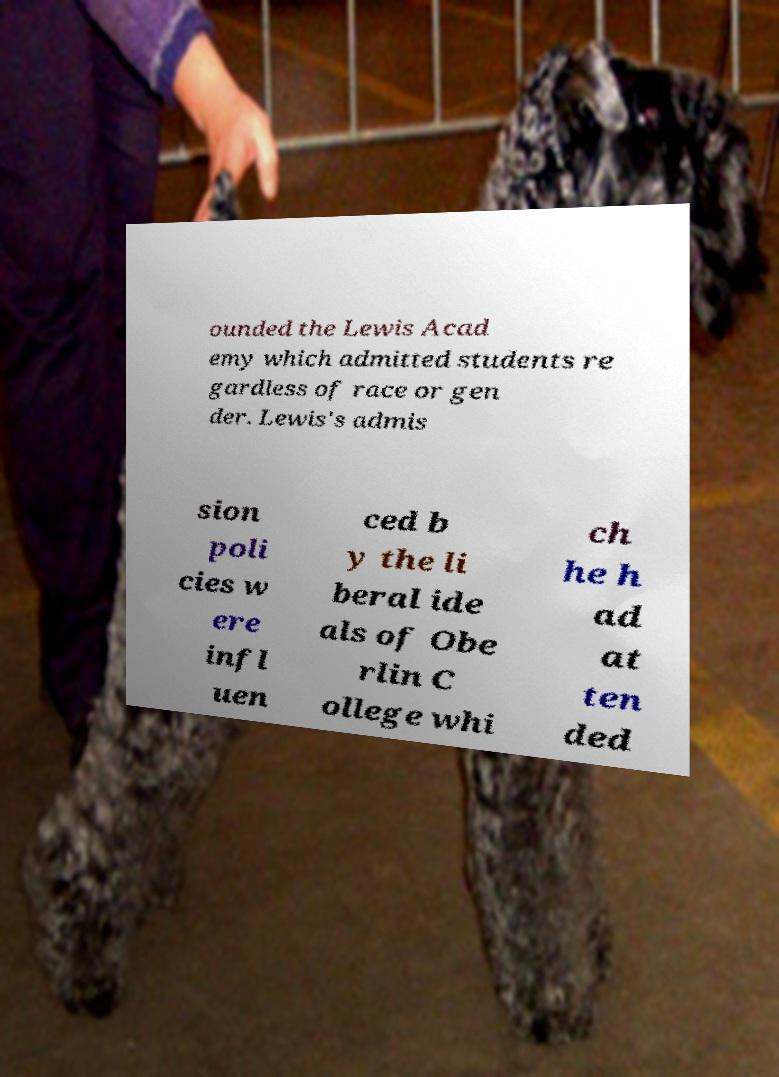Could you assist in decoding the text presented in this image and type it out clearly? ounded the Lewis Acad emy which admitted students re gardless of race or gen der. Lewis's admis sion poli cies w ere infl uen ced b y the li beral ide als of Obe rlin C ollege whi ch he h ad at ten ded 